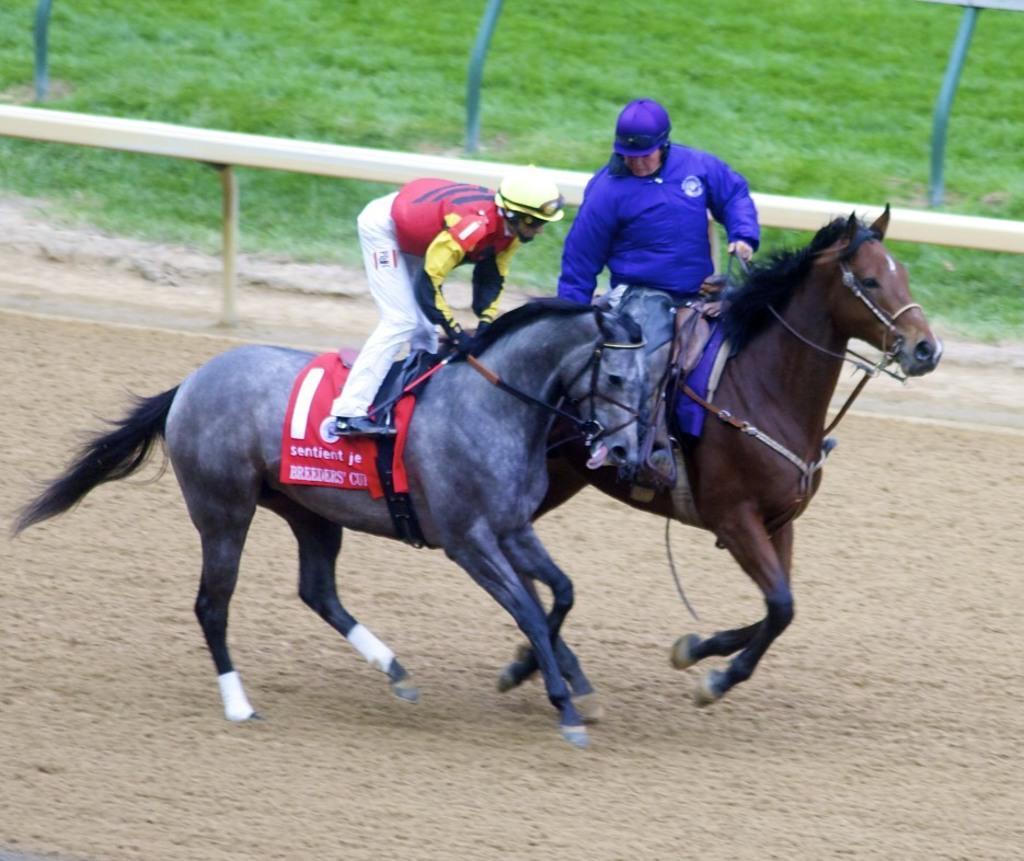Describe this image in one or two sentences. In this picture we observe two guys are riding horses and we observe one of it is black horse and the other is brown horse. In the background we observe a grassland. 